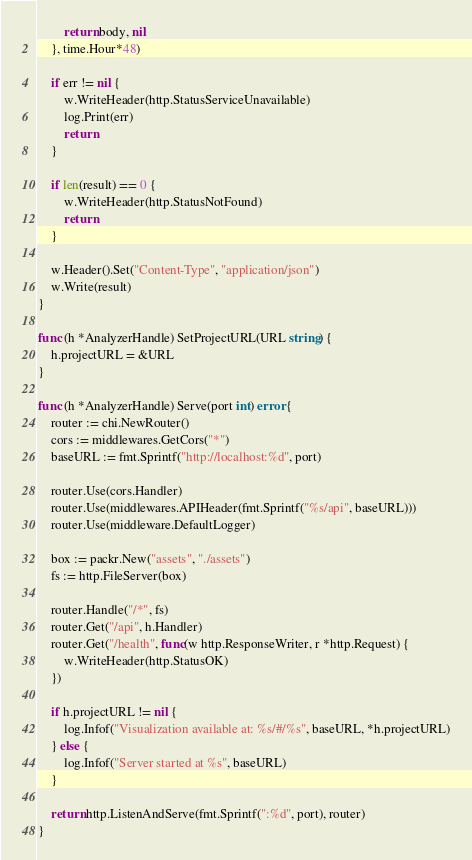<code> <loc_0><loc_0><loc_500><loc_500><_Go_>
		return body, nil
	}, time.Hour*48)

	if err != nil {
		w.WriteHeader(http.StatusServiceUnavailable)
		log.Print(err)
		return
	}

	if len(result) == 0 {
		w.WriteHeader(http.StatusNotFound)
		return
	}

	w.Header().Set("Content-Type", "application/json")
	w.Write(result)
}

func (h *AnalyzerHandle) SetProjectURL(URL string) {
	h.projectURL = &URL
}

func (h *AnalyzerHandle) Serve(port int) error {
	router := chi.NewRouter()
	cors := middlewares.GetCors("*")
	baseURL := fmt.Sprintf("http://localhost:%d", port)

	router.Use(cors.Handler)
	router.Use(middlewares.APIHeader(fmt.Sprintf("%s/api", baseURL)))
	router.Use(middleware.DefaultLogger)

	box := packr.New("assets", "./assets")
	fs := http.FileServer(box)

	router.Handle("/*", fs)
	router.Get("/api", h.Handler)
	router.Get("/health", func(w http.ResponseWriter, r *http.Request) {
		w.WriteHeader(http.StatusOK)
	})

	if h.projectURL != nil {
		log.Infof("Visualization available at: %s/#/%s", baseURL, *h.projectURL)
	} else {
		log.Infof("Server started at %s", baseURL)
	}

	return http.ListenAndServe(fmt.Sprintf(":%d", port), router)
}
</code> 